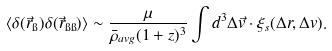<formula> <loc_0><loc_0><loc_500><loc_500>\langle \delta ( \vec { r } _ { \i } ) \delta ( \vec { r } _ { { \i } { \i } } ) \rangle \sim \frac { \mu } { \bar { \rho } _ { a v g } ( 1 + z ) ^ { 3 } } \int d ^ { 3 } \Delta \vec { v } \cdot \xi _ { s } ( \Delta { r } , \Delta v ) .</formula> 